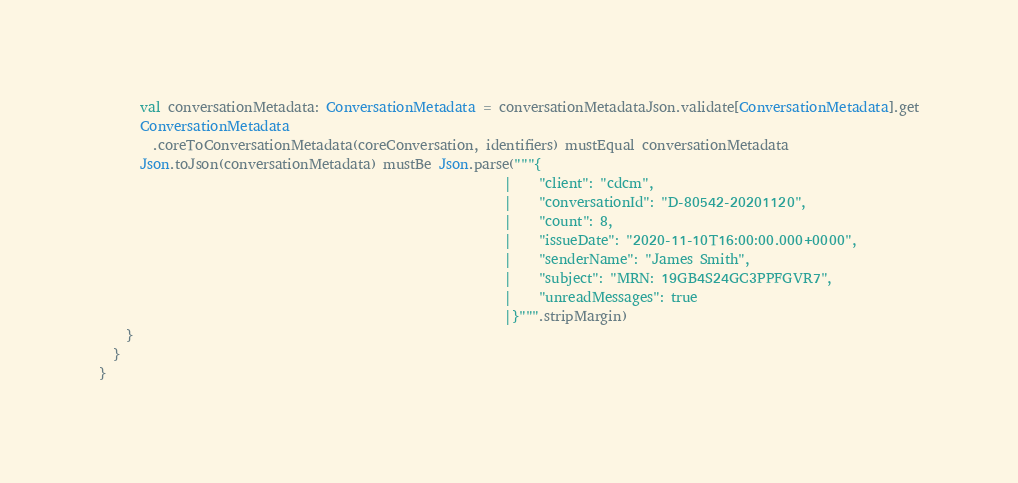Convert code to text. <code><loc_0><loc_0><loc_500><loc_500><_Scala_>      val conversationMetadata: ConversationMetadata = conversationMetadataJson.validate[ConversationMetadata].get
      ConversationMetadata
        .coreToConversationMetadata(coreConversation, identifiers) mustEqual conversationMetadata
      Json.toJson(conversationMetadata) mustBe Json.parse("""{
                                                            |    "client": "cdcm",
                                                            |    "conversationId": "D-80542-20201120",
                                                            |    "count": 8,
                                                            |    "issueDate": "2020-11-10T16:00:00.000+0000",
                                                            |    "senderName": "James Smith",
                                                            |    "subject": "MRN: 19GB4S24GC3PPFGVR7",
                                                            |    "unreadMessages": true
                                                            |}""".stripMargin)
    }
  }
}
</code> 